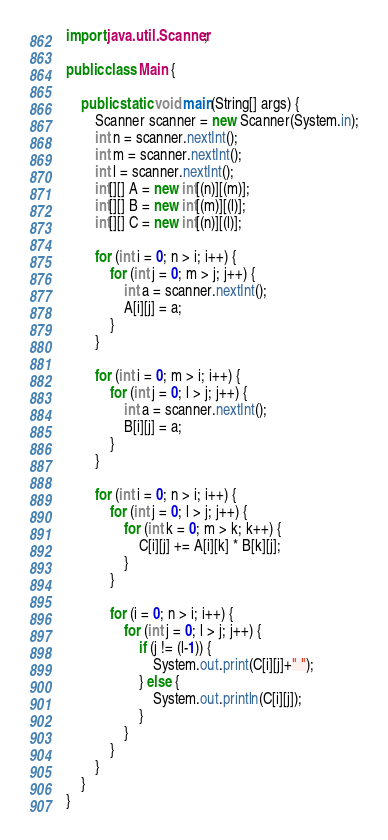Convert code to text. <code><loc_0><loc_0><loc_500><loc_500><_Java_>import java.util.Scanner;

public class Main {

    public static void main(String[] args) {
        Scanner scanner = new Scanner(System.in);
        int n = scanner.nextInt();
        int m = scanner.nextInt();
        int l = scanner.nextInt();
        int[][] A = new int[(n)][(m)];
        int[][] B = new int[(m)][(l)];
        int[][] C = new int[(n)][(l)];

        for (int i = 0; n > i; i++) {
            for (int j = 0; m > j; j++) {
                int a = scanner.nextInt();
                A[i][j] = a;
            }
        }

        for (int i = 0; m > i; i++) {
            for (int j = 0; l > j; j++) {
                int a = scanner.nextInt();
                B[i][j] = a;
            }
        }

        for (int i = 0; n > i; i++) {
            for (int j = 0; l > j; j++) {
                for (int k = 0; m > k; k++) {
                    C[i][j] += A[i][k] * B[k][j];
                }
            }

            for (i = 0; n > i; i++) {
                for (int j = 0; l > j; j++) {
                    if (j != (l-1)) {
                        System.out.print(C[i][j]+" ");
                    } else {
                        System.out.println(C[i][j]);
                    }
                }
            }
        }
    }
}</code> 